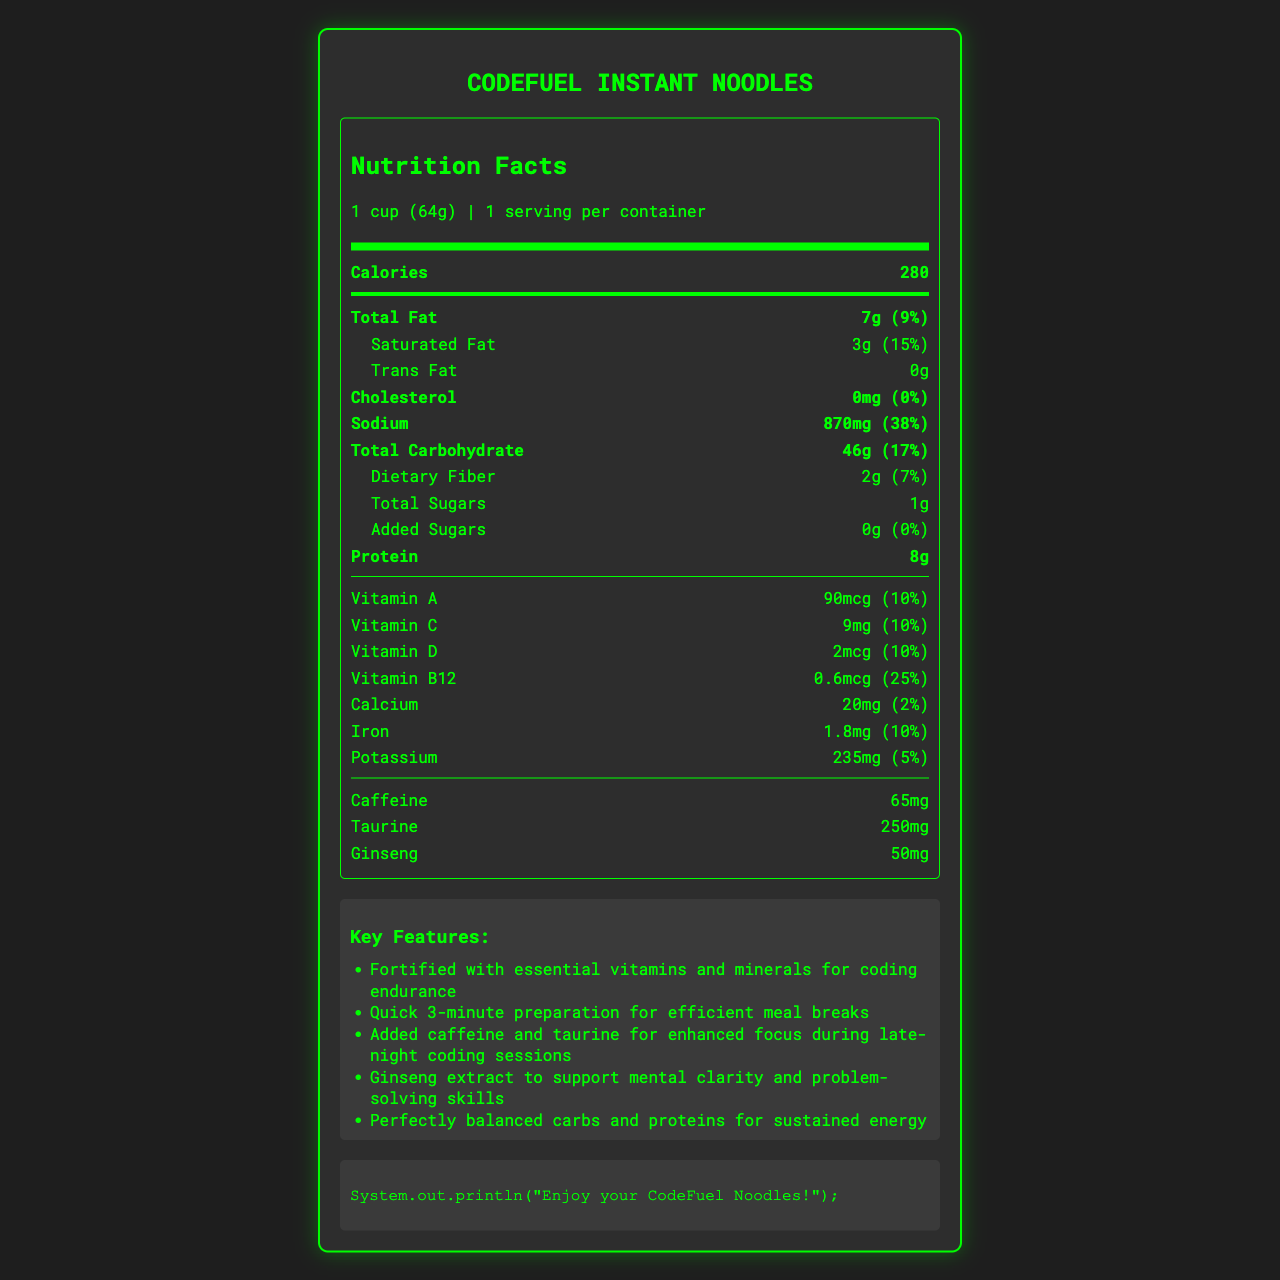what is the serving size of CodeFuel Instant Noodles? The serving size is listed at the beginning of the nutrition facts section as "1 cup (64g)".
Answer: 1 cup (64g) how many calories are in a serving? The calories per serving is indicated in the bold section saying "Calories 280".
Answer: 280 what is the amount of sodium in one serving of CodeFuel Instant Noodles? The sodium content is listed in the detailed breakdown, showing "Sodium 870mg (38%)".
Answer: 870 mg how many grams of total fat are in one serving? The total fat content is listed in the nutrition label as "Total Fat 7g (9%)".
Answer: 7g how much protein is in one serving? The protein content is indicated in the nutrition label stating "Protein 8g".
Answer: 8g what are the main types of vitamins included in CodeFuel Instant Noodles? The nutrition label lists these vitamins with their amounts and daily values in the lower section of the nutrition facts.
Answer: Vitamin A, Vitamin C, Vitamin D, Vitamin B12 which nutrient has the highest daily value percentage? A. Sodium B. Vitamin B12 C. Iron D. Saturated Fat Sodium has the highest daily value percentage listed in the document at 38%.
Answer: A how long does it take to prepare CodeFuel Instant Noodles? A. 2 minutes B. 3 minutes C. 5 minutes D. 10 minutes The preparation time is listed in the summary section as "Quick 3-minute preparation for efficient meal breaks".
Answer: B does this product contain any allergens? The product allergen information states it contains wheat and soy and is processed in a facility that also processes egg and milk.
Answer: Yes what is the marketing claim related to mental clarity? One of the marketing claims specifically mentions "Ginseng extract to support mental clarity and problem-solving skills".
Answer: Ginseng extract to support mental clarity and problem-solving skills list two added ingredients that enhance focus. The marketing claims section mentions caffeine and taurine for "enhanced focus during late-night coding sessions".
Answer: Caffeine and Taurine is there any cholesterol in this product? The nutrition facts state "Cholesterol 0mg (0%)", indicating there is no cholesterol.
Answer: No summarize the key features and nutritional highlights of CodeFuel Instant Noodles. This summary captures the product’s quick preparation, added focus and mental clarity features, and the main nutritional details provided in the document.
Answer: CodeFuel Instant Noodles are fortified with essential vitamins and minerals, and designed for quick 3-minute preparation. It contains added caffeine and taurine for focus, ginseng for mental clarity, balanced carbs and proteins for energy, and includes 280 calories, 7g of total fat, 870mg of sodium, 46g of carbohydrates, 8g of protein and essential vitamins such as A, C, D, and B12. how much added sugar is in one serving of CodeFuel Instant Noodles? The label indicates "Added Sugars 0g (0%)", meaning there is no added sugar in one serving.
Answer: 0g what is the reference code included in the document? The reference code displayed at the bottom of the document is "System.out.println('Enjoy your CodeFuel Noodles!');".
Answer: System.out.println("Enjoy your CodeFuel Noodles!"); how much calcium is in one serving? The nutrition facts list calcium content as "Calcium 20mg (2%)".
Answer: 20 mg is there any information on the product's packaging design? The document does not provide any details on the product’s packaging design.
Answer: Not enough information 